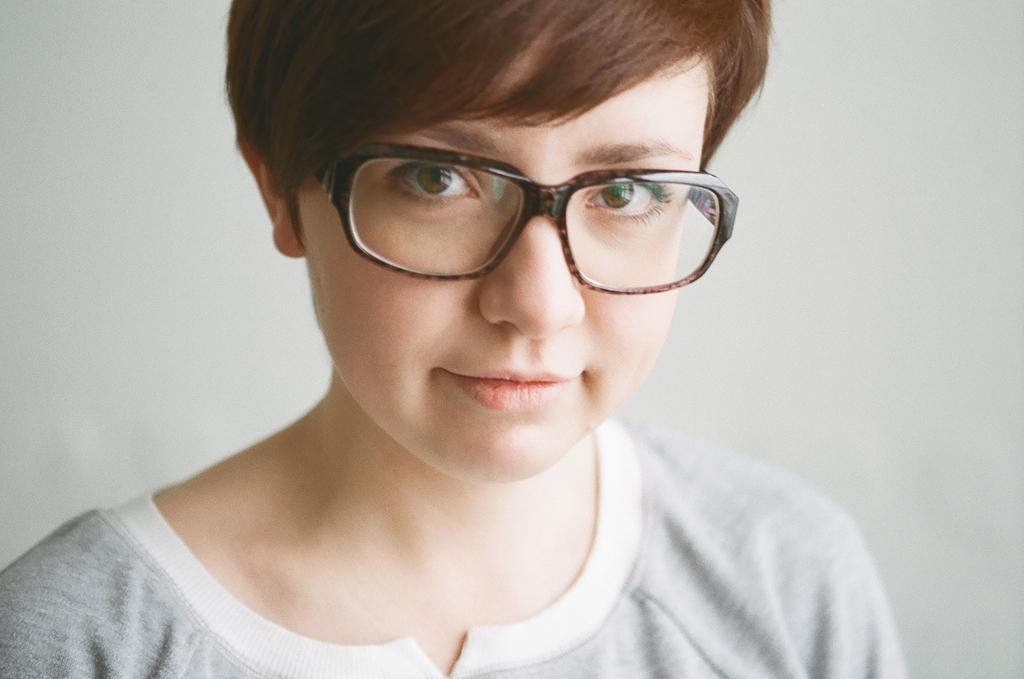What is present in the image? There is a person in the image. Can you describe the person's appearance? The person is wearing spectacles. What can be seen behind the person in the image? There is a background visible in the image. What type of skirt is the person wearing in the image? There is no skirt visible in the image; the person is wearing spectacles. What type of liquid can be seen being poured in the image? There is no liquid being poured in the image. 